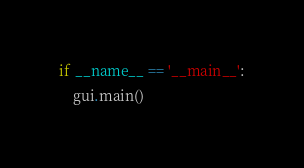Convert code to text. <code><loc_0><loc_0><loc_500><loc_500><_Python_>if __name__ == '__main__':
    gui.main()
</code> 